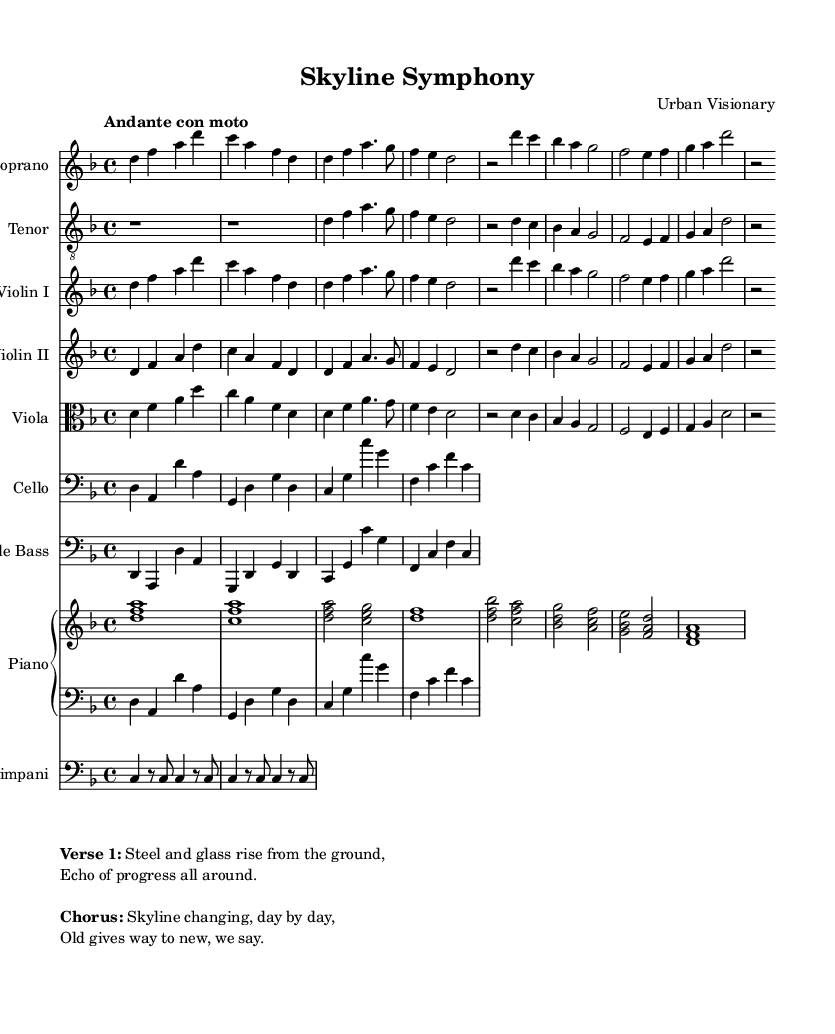What is the key signature of this music? The key signature is D minor, which has one flat (B flat). This can be determined from the beginning of the staff where the key signature is indicated.
Answer: D minor What is the time signature of this music? The time signature is 4/4, which indicates there are four beats in each measure and a quarter note receives one beat. This is typically found at the beginning of the score as well.
Answer: 4/4 What is the tempo marking given for this piece? The tempo marking is "Andante con moto," which means moderately slow with movement. This is indicated at the beginning of the score.
Answer: Andante con moto What instruments are included in this score? The score includes Soprano, Tenor, Violin I, Violin II, Viola, Cello, Double Bass, Piano, and Timpani. These are all listed at the beginning of the score under the staff labels.
Answer: Soprano, Tenor, Violin I, Violin II, Viola, Cello, Double Bass, Piano, Timpani What is the main theme depicted in the chorus? The main theme in the chorus suggests transformation, with lyrics that emphasize change over time. This can be found in the lyrics provided under the chorus section of the markup.
Answer: Skyline changing, day by day How many measures are there in the Introduction section? The Introduction consists of 4 measures. This can be verified by counting the measures notated in the sheet music from the beginning until the verse.
Answer: 4 What does the phrase "Old gives way to new" signify in the context of the opera? This phrase indicates a theme of urban development and transformation, reflecting the narrative of modern architecture replacing the old structures in urban landscapes. It connects to the overall message of change highlighted in the chorus.
Answer: Transformation 